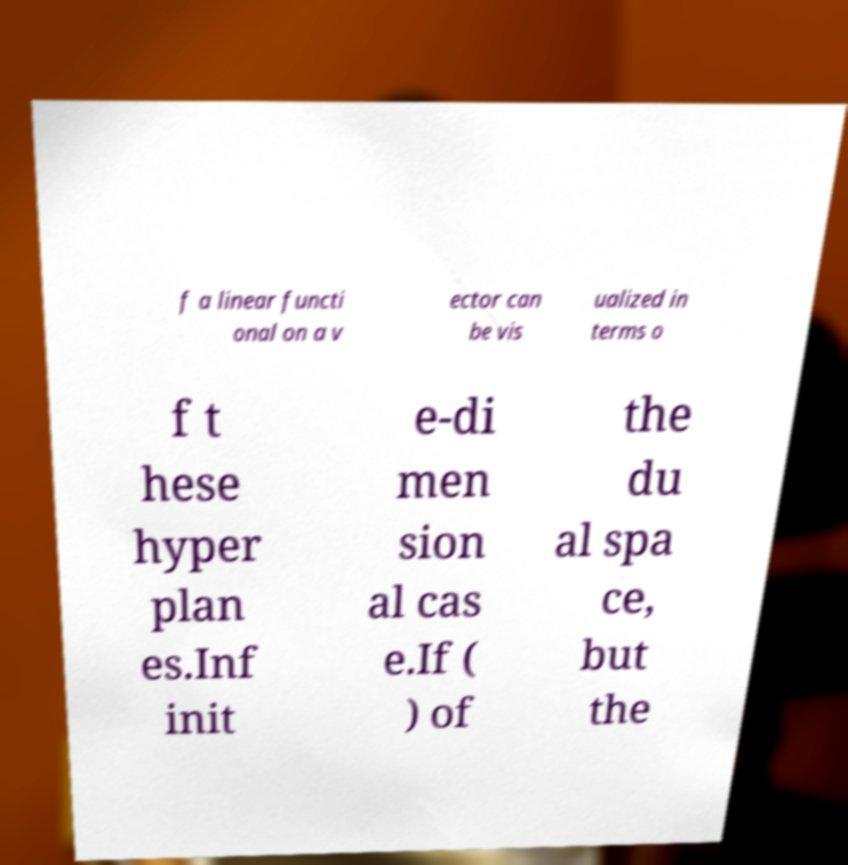Please read and relay the text visible in this image. What does it say? f a linear functi onal on a v ector can be vis ualized in terms o f t hese hyper plan es.Inf init e-di men sion al cas e.If ( ) of the du al spa ce, but the 